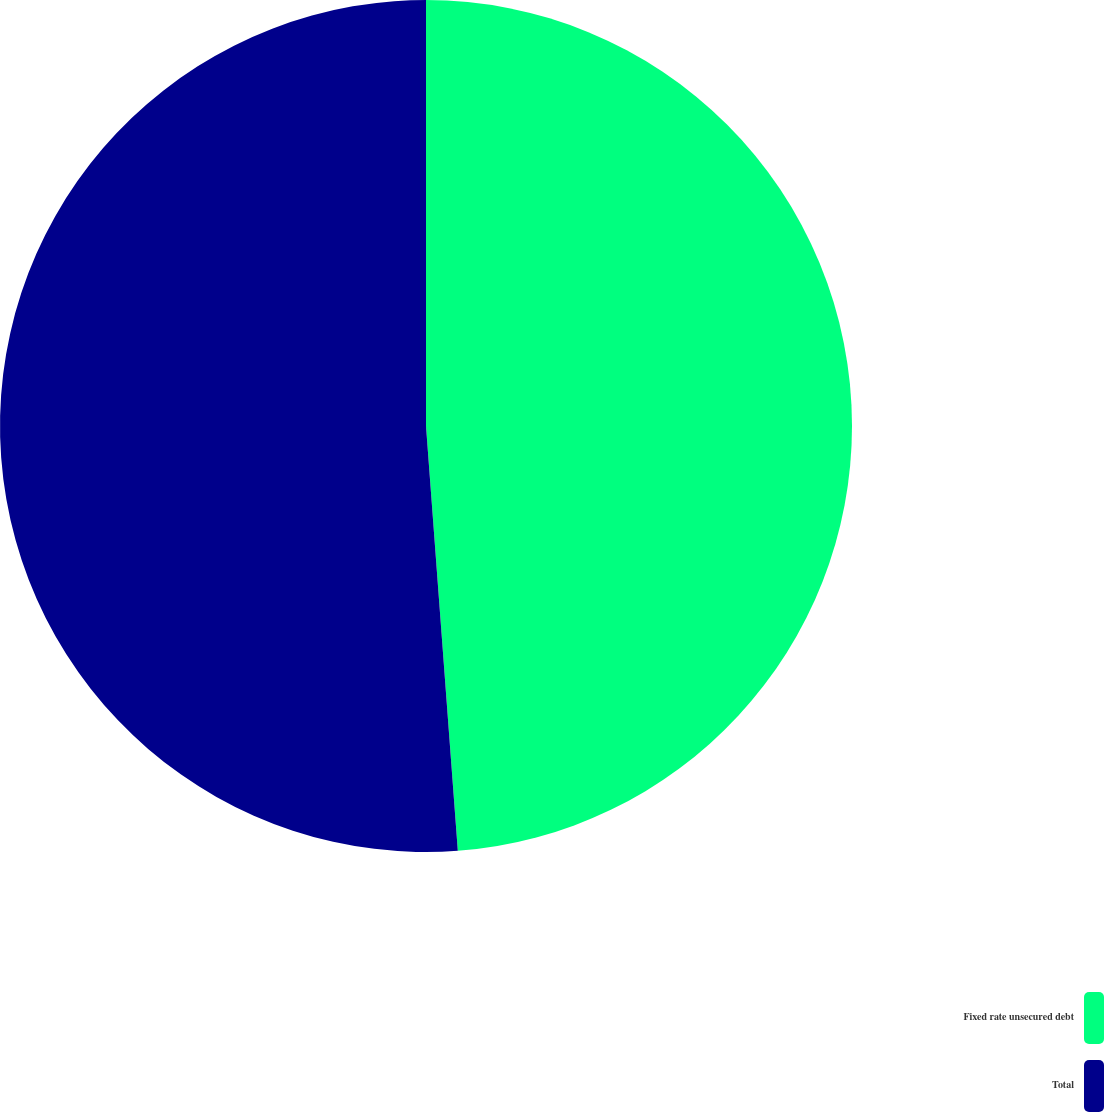Convert chart to OTSL. <chart><loc_0><loc_0><loc_500><loc_500><pie_chart><fcel>Fixed rate unsecured debt<fcel>Total<nl><fcel>48.81%<fcel>51.19%<nl></chart> 